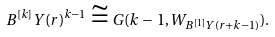Convert formula to latex. <formula><loc_0><loc_0><loc_500><loc_500>B ^ { [ k ] } Y ( r ) ^ { k - 1 } \cong G ( k \, - \, 1 , W _ { B ^ { [ 1 ] } Y ( r + k - 1 ) } ) .</formula> 